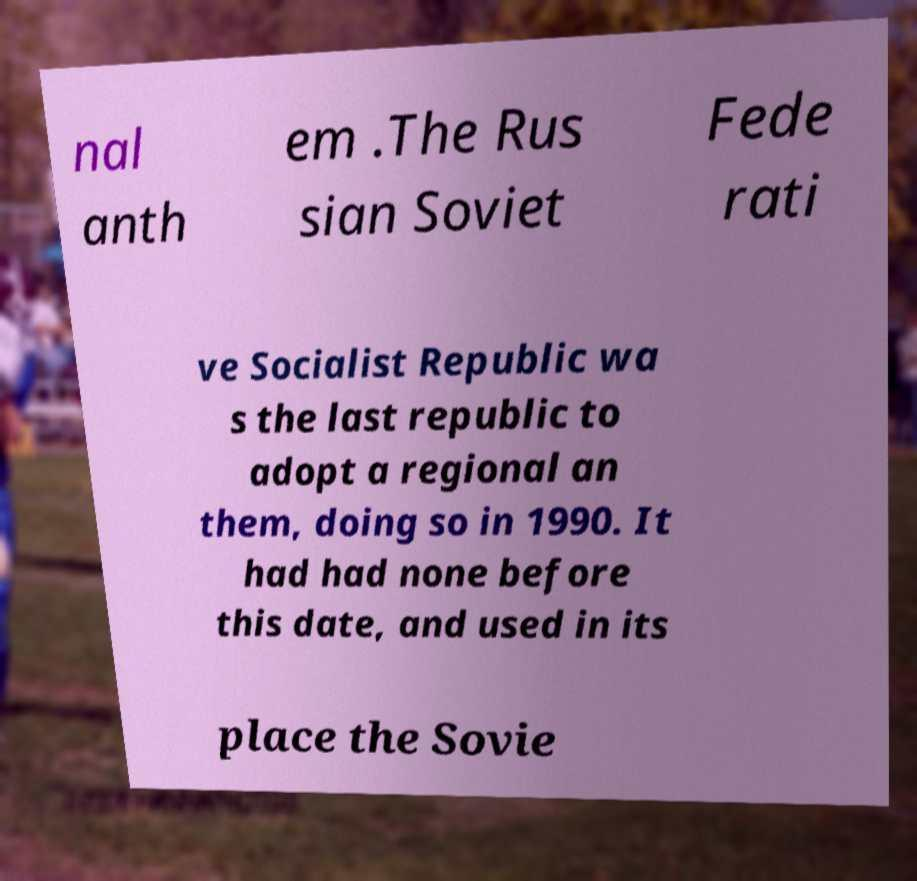Please identify and transcribe the text found in this image. nal anth em .The Rus sian Soviet Fede rati ve Socialist Republic wa s the last republic to adopt a regional an them, doing so in 1990. It had had none before this date, and used in its place the Sovie 